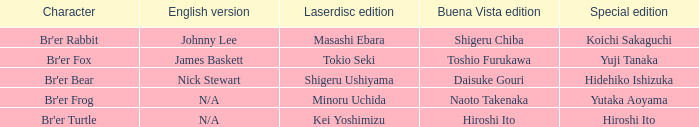Give me the full table as a dictionary. {'header': ['Character', 'English version', 'Laserdisc edition', 'Buena Vista edition', 'Special edition'], 'rows': [["Br'er Rabbit", 'Johnny Lee', 'Masashi Ebara', 'Shigeru Chiba', 'Koichi Sakaguchi'], ["Br'er Fox", 'James Baskett', 'Tokio Seki', 'Toshio Furukawa', 'Yuji Tanaka'], ["Br'er Bear", 'Nick Stewart', 'Shigeru Ushiyama', 'Daisuke Gouri', 'Hidehiko Ishizuka'], ["Br'er Frog", 'N/A', 'Minoru Uchida', 'Naoto Takenaka', 'Yutaka Aoyama'], ["Br'er Turtle", 'N/A', 'Kei Yoshimizu', 'Hiroshi Ito', 'Hiroshi Ito']]} Who is the buena vista edidtion where special edition is koichi sakaguchi? Shigeru Chiba. 